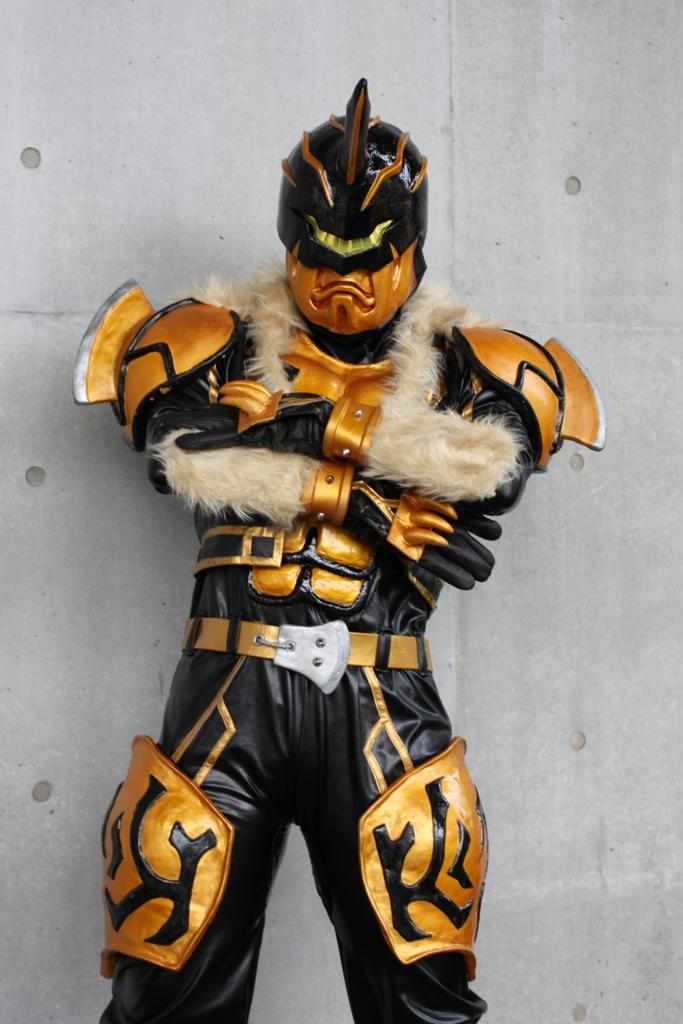What is the person in the image wearing? The person is wearing a costume in the image. What colors are featured on the costume? The costume is black and golden in color. What can be seen in the background of the image? There is a white-colored wall in the background of the image. What type of alley can be seen behind the person in the image? There is no alley present in the image; it features a person wearing a costume in front of a white-colored wall. 